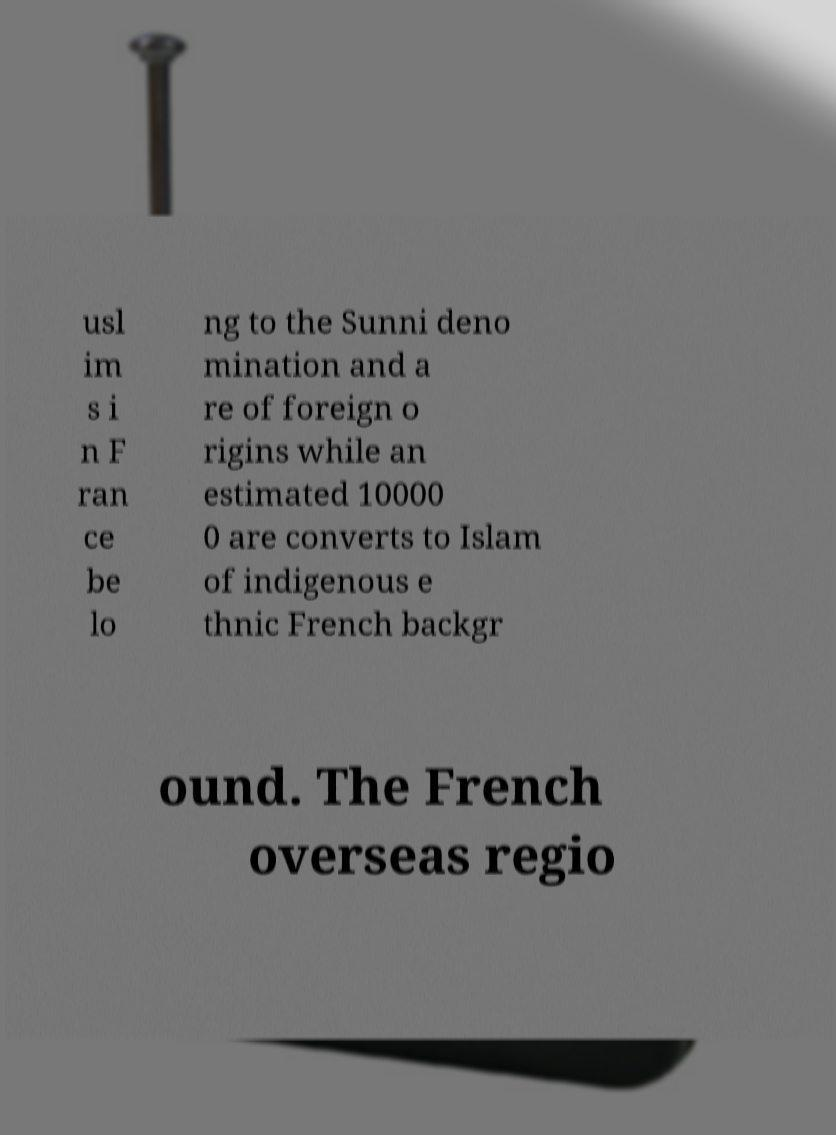Please read and relay the text visible in this image. What does it say? usl im s i n F ran ce be lo ng to the Sunni deno mination and a re of foreign o rigins while an estimated 10000 0 are converts to Islam of indigenous e thnic French backgr ound. The French overseas regio 